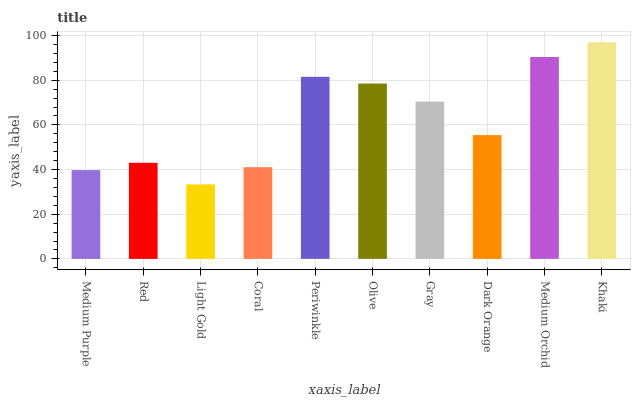Is Light Gold the minimum?
Answer yes or no. Yes. Is Khaki the maximum?
Answer yes or no. Yes. Is Red the minimum?
Answer yes or no. No. Is Red the maximum?
Answer yes or no. No. Is Red greater than Medium Purple?
Answer yes or no. Yes. Is Medium Purple less than Red?
Answer yes or no. Yes. Is Medium Purple greater than Red?
Answer yes or no. No. Is Red less than Medium Purple?
Answer yes or no. No. Is Gray the high median?
Answer yes or no. Yes. Is Dark Orange the low median?
Answer yes or no. Yes. Is Dark Orange the high median?
Answer yes or no. No. Is Khaki the low median?
Answer yes or no. No. 